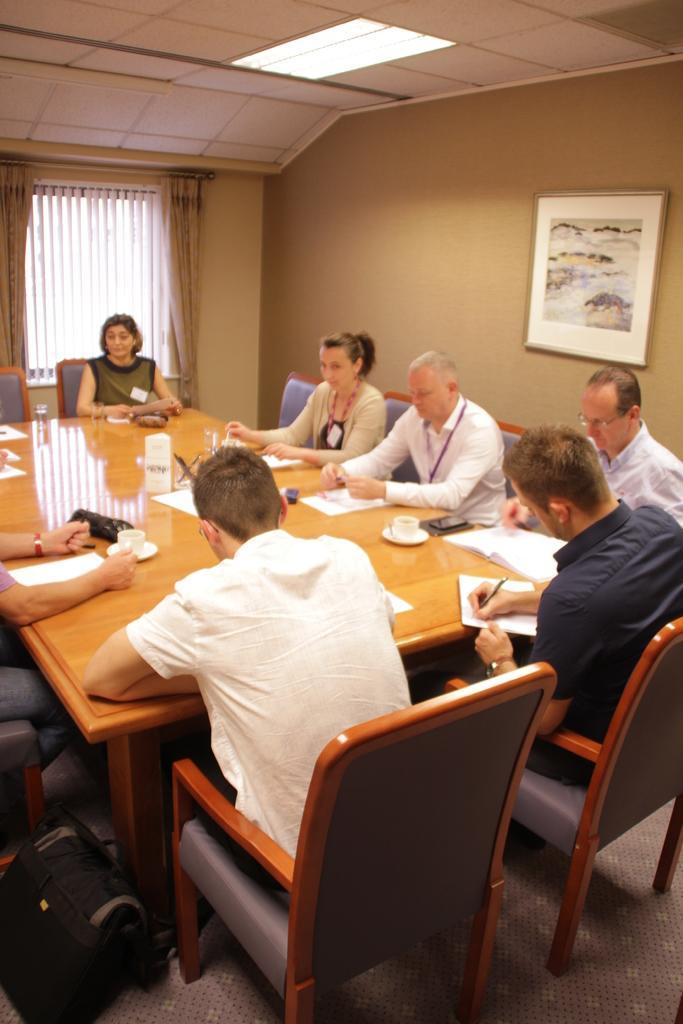Can you describe this image briefly? In the image we can see group of persons were sitting on the chair around the table. On table,there is a cup,torch light,mug,papers,saucer,pen,book,phone and glass. On the left corner there is a backpack. In the background we can see curtain,light,wall and photo frame. 